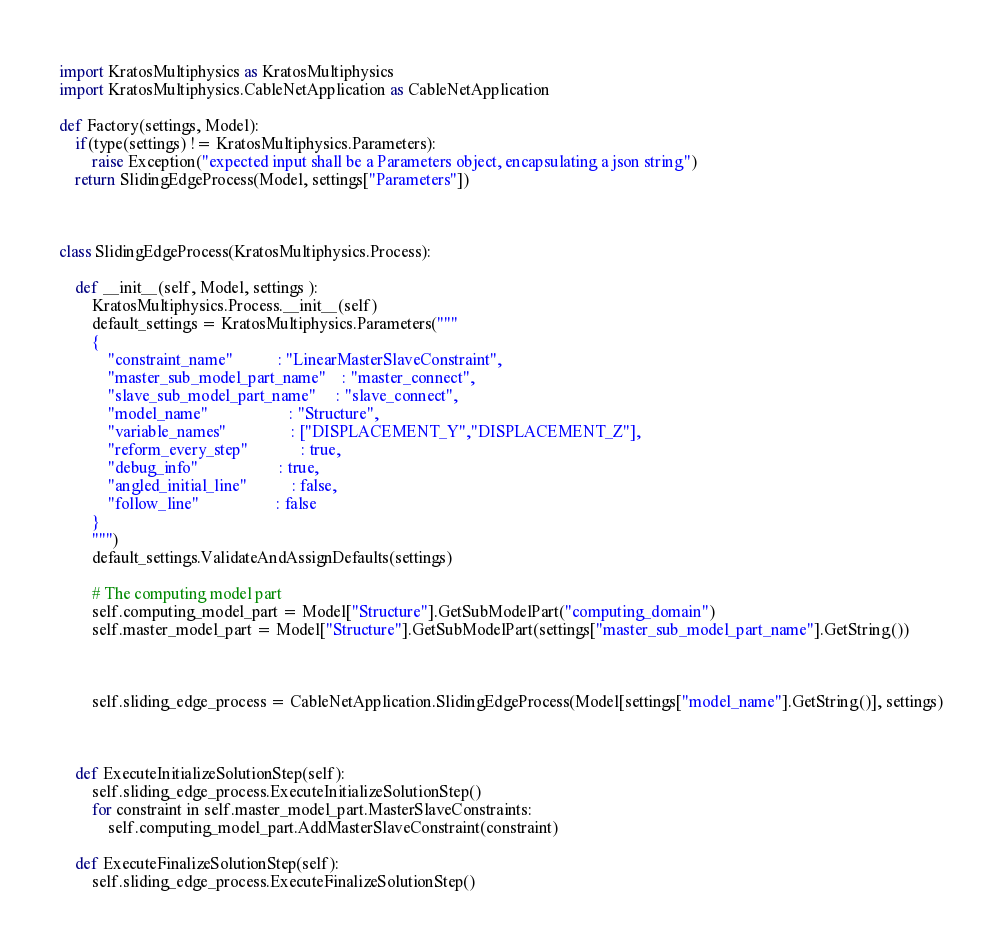<code> <loc_0><loc_0><loc_500><loc_500><_Python_>import KratosMultiphysics as KratosMultiphysics
import KratosMultiphysics.CableNetApplication as CableNetApplication

def Factory(settings, Model):
    if(type(settings) != KratosMultiphysics.Parameters):
        raise Exception("expected input shall be a Parameters object, encapsulating a json string")
    return SlidingEdgeProcess(Model, settings["Parameters"])



class SlidingEdgeProcess(KratosMultiphysics.Process):

    def __init__(self, Model, settings ):
        KratosMultiphysics.Process.__init__(self)
        default_settings = KratosMultiphysics.Parameters("""
        {
            "constraint_name"           : "LinearMasterSlaveConstraint",
            "master_sub_model_part_name"    : "master_connect",
            "slave_sub_model_part_name"     : "slave_connect",
            "model_name"                    : "Structure",
            "variable_names"                : ["DISPLACEMENT_Y","DISPLACEMENT_Z"],
            "reform_every_step"             : true,
            "debug_info"                    : true,
            "angled_initial_line"           : false,
            "follow_line"                   : false
        }
        """)
        default_settings.ValidateAndAssignDefaults(settings)

        # The computing model part
        self.computing_model_part = Model["Structure"].GetSubModelPart("computing_domain")
        self.master_model_part = Model["Structure"].GetSubModelPart(settings["master_sub_model_part_name"].GetString())



        self.sliding_edge_process = CableNetApplication.SlidingEdgeProcess(Model[settings["model_name"].GetString()], settings)



    def ExecuteInitializeSolutionStep(self):
        self.sliding_edge_process.ExecuteInitializeSolutionStep()
        for constraint in self.master_model_part.MasterSlaveConstraints:
            self.computing_model_part.AddMasterSlaveConstraint(constraint)

    def ExecuteFinalizeSolutionStep(self):
        self.sliding_edge_process.ExecuteFinalizeSolutionStep()</code> 